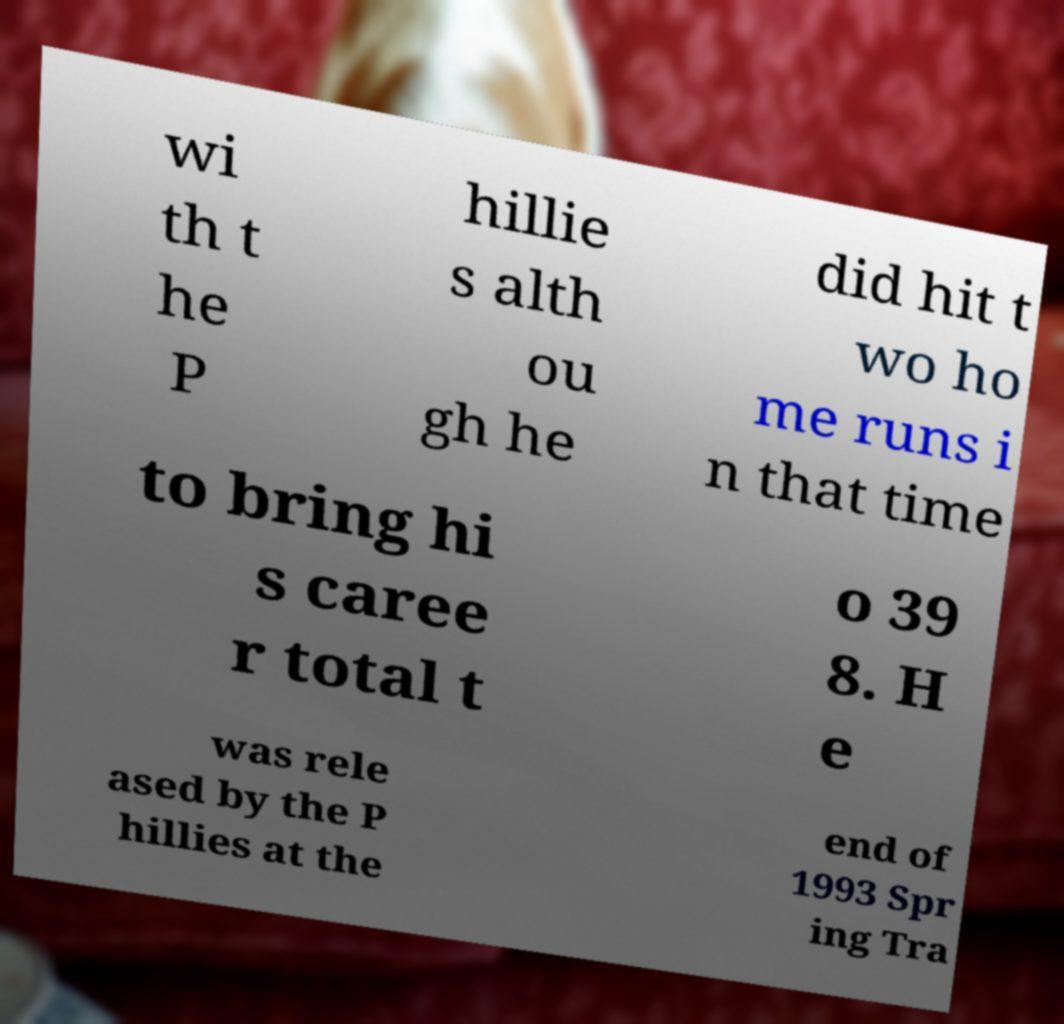Can you accurately transcribe the text from the provided image for me? wi th t he P hillie s alth ou gh he did hit t wo ho me runs i n that time to bring hi s caree r total t o 39 8. H e was rele ased by the P hillies at the end of 1993 Spr ing Tra 